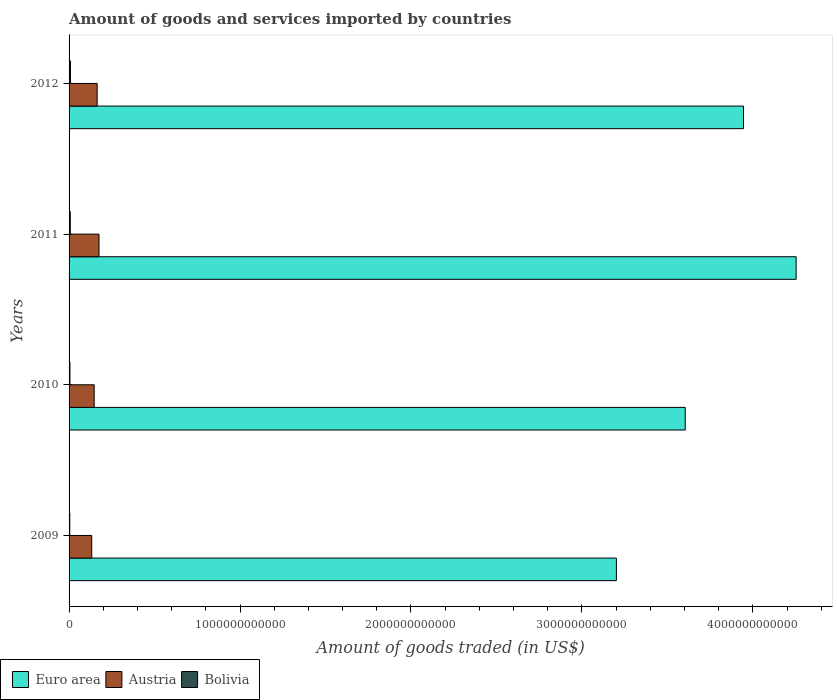How many different coloured bars are there?
Your answer should be very brief. 3. How many groups of bars are there?
Offer a very short reply. 4. How many bars are there on the 4th tick from the bottom?
Ensure brevity in your answer.  3. In how many cases, is the number of bars for a given year not equal to the number of legend labels?
Provide a succinct answer. 0. What is the total amount of goods and services imported in Euro area in 2010?
Your answer should be very brief. 3.60e+12. Across all years, what is the maximum total amount of goods and services imported in Bolivia?
Your answer should be compact. 8.00e+09. Across all years, what is the minimum total amount of goods and services imported in Euro area?
Your answer should be compact. 3.20e+12. In which year was the total amount of goods and services imported in Bolivia maximum?
Offer a terse response. 2012. In which year was the total amount of goods and services imported in Austria minimum?
Provide a short and direct response. 2009. What is the total total amount of goods and services imported in Bolivia in the graph?
Offer a terse response. 2.43e+1. What is the difference between the total amount of goods and services imported in Austria in 2010 and that in 2012?
Offer a terse response. -1.74e+1. What is the difference between the total amount of goods and services imported in Euro area in 2010 and the total amount of goods and services imported in Bolivia in 2009?
Provide a succinct answer. 3.60e+12. What is the average total amount of goods and services imported in Austria per year?
Your answer should be very brief. 1.55e+11. In the year 2009, what is the difference between the total amount of goods and services imported in Euro area and total amount of goods and services imported in Austria?
Your answer should be very brief. 3.07e+12. What is the ratio of the total amount of goods and services imported in Euro area in 2009 to that in 2010?
Your answer should be compact. 0.89. Is the total amount of goods and services imported in Austria in 2010 less than that in 2012?
Ensure brevity in your answer.  Yes. Is the difference between the total amount of goods and services imported in Euro area in 2010 and 2011 greater than the difference between the total amount of goods and services imported in Austria in 2010 and 2011?
Your answer should be very brief. No. What is the difference between the highest and the second highest total amount of goods and services imported in Euro area?
Your response must be concise. 3.08e+11. What is the difference between the highest and the lowest total amount of goods and services imported in Euro area?
Ensure brevity in your answer.  1.05e+12. Is the sum of the total amount of goods and services imported in Austria in 2009 and 2010 greater than the maximum total amount of goods and services imported in Euro area across all years?
Give a very brief answer. No. How many years are there in the graph?
Your answer should be very brief. 4. What is the difference between two consecutive major ticks on the X-axis?
Provide a succinct answer. 1.00e+12. Are the values on the major ticks of X-axis written in scientific E-notation?
Give a very brief answer. No. Does the graph contain any zero values?
Offer a very short reply. No. Does the graph contain grids?
Give a very brief answer. No. How are the legend labels stacked?
Provide a short and direct response. Horizontal. What is the title of the graph?
Provide a succinct answer. Amount of goods and services imported by countries. Does "Aruba" appear as one of the legend labels in the graph?
Ensure brevity in your answer.  No. What is the label or title of the X-axis?
Give a very brief answer. Amount of goods traded (in US$). What is the label or title of the Y-axis?
Keep it short and to the point. Years. What is the Amount of goods traded (in US$) of Euro area in 2009?
Make the answer very short. 3.20e+12. What is the Amount of goods traded (in US$) of Austria in 2009?
Ensure brevity in your answer.  1.32e+11. What is the Amount of goods traded (in US$) in Bolivia in 2009?
Make the answer very short. 4.14e+09. What is the Amount of goods traded (in US$) of Euro area in 2010?
Offer a very short reply. 3.60e+12. What is the Amount of goods traded (in US$) in Austria in 2010?
Offer a very short reply. 1.47e+11. What is the Amount of goods traded (in US$) of Bolivia in 2010?
Provide a short and direct response. 5.01e+09. What is the Amount of goods traded (in US$) of Euro area in 2011?
Keep it short and to the point. 4.25e+12. What is the Amount of goods traded (in US$) of Austria in 2011?
Your answer should be very brief. 1.75e+11. What is the Amount of goods traded (in US$) in Bolivia in 2011?
Your answer should be very brief. 7.13e+09. What is the Amount of goods traded (in US$) of Euro area in 2012?
Your answer should be compact. 3.95e+12. What is the Amount of goods traded (in US$) of Austria in 2012?
Offer a terse response. 1.64e+11. What is the Amount of goods traded (in US$) in Bolivia in 2012?
Your response must be concise. 8.00e+09. Across all years, what is the maximum Amount of goods traded (in US$) in Euro area?
Provide a short and direct response. 4.25e+12. Across all years, what is the maximum Amount of goods traded (in US$) in Austria?
Provide a succinct answer. 1.75e+11. Across all years, what is the maximum Amount of goods traded (in US$) in Bolivia?
Ensure brevity in your answer.  8.00e+09. Across all years, what is the minimum Amount of goods traded (in US$) of Euro area?
Keep it short and to the point. 3.20e+12. Across all years, what is the minimum Amount of goods traded (in US$) in Austria?
Your answer should be compact. 1.32e+11. Across all years, what is the minimum Amount of goods traded (in US$) of Bolivia?
Offer a terse response. 4.14e+09. What is the total Amount of goods traded (in US$) of Euro area in the graph?
Your answer should be compact. 1.50e+13. What is the total Amount of goods traded (in US$) of Austria in the graph?
Give a very brief answer. 6.19e+11. What is the total Amount of goods traded (in US$) of Bolivia in the graph?
Make the answer very short. 2.43e+1. What is the difference between the Amount of goods traded (in US$) in Euro area in 2009 and that in 2010?
Make the answer very short. -4.03e+11. What is the difference between the Amount of goods traded (in US$) in Austria in 2009 and that in 2010?
Make the answer very short. -1.45e+1. What is the difference between the Amount of goods traded (in US$) in Bolivia in 2009 and that in 2010?
Ensure brevity in your answer.  -8.63e+08. What is the difference between the Amount of goods traded (in US$) in Euro area in 2009 and that in 2011?
Offer a very short reply. -1.05e+12. What is the difference between the Amount of goods traded (in US$) in Austria in 2009 and that in 2011?
Your answer should be very brief. -4.28e+1. What is the difference between the Amount of goods traded (in US$) in Bolivia in 2009 and that in 2011?
Provide a succinct answer. -2.98e+09. What is the difference between the Amount of goods traded (in US$) in Euro area in 2009 and that in 2012?
Ensure brevity in your answer.  -7.43e+11. What is the difference between the Amount of goods traded (in US$) of Austria in 2009 and that in 2012?
Offer a terse response. -3.19e+1. What is the difference between the Amount of goods traded (in US$) in Bolivia in 2009 and that in 2012?
Offer a very short reply. -3.85e+09. What is the difference between the Amount of goods traded (in US$) of Euro area in 2010 and that in 2011?
Offer a very short reply. -6.49e+11. What is the difference between the Amount of goods traded (in US$) of Austria in 2010 and that in 2011?
Offer a terse response. -2.83e+1. What is the difference between the Amount of goods traded (in US$) in Bolivia in 2010 and that in 2011?
Offer a terse response. -2.12e+09. What is the difference between the Amount of goods traded (in US$) in Euro area in 2010 and that in 2012?
Offer a terse response. -3.41e+11. What is the difference between the Amount of goods traded (in US$) of Austria in 2010 and that in 2012?
Offer a terse response. -1.74e+1. What is the difference between the Amount of goods traded (in US$) in Bolivia in 2010 and that in 2012?
Offer a terse response. -2.99e+09. What is the difference between the Amount of goods traded (in US$) in Euro area in 2011 and that in 2012?
Keep it short and to the point. 3.08e+11. What is the difference between the Amount of goods traded (in US$) in Austria in 2011 and that in 2012?
Provide a succinct answer. 1.09e+1. What is the difference between the Amount of goods traded (in US$) of Bolivia in 2011 and that in 2012?
Offer a very short reply. -8.71e+08. What is the difference between the Amount of goods traded (in US$) in Euro area in 2009 and the Amount of goods traded (in US$) in Austria in 2010?
Ensure brevity in your answer.  3.06e+12. What is the difference between the Amount of goods traded (in US$) in Euro area in 2009 and the Amount of goods traded (in US$) in Bolivia in 2010?
Your answer should be compact. 3.20e+12. What is the difference between the Amount of goods traded (in US$) of Austria in 2009 and the Amount of goods traded (in US$) of Bolivia in 2010?
Your response must be concise. 1.27e+11. What is the difference between the Amount of goods traded (in US$) in Euro area in 2009 and the Amount of goods traded (in US$) in Austria in 2011?
Make the answer very short. 3.03e+12. What is the difference between the Amount of goods traded (in US$) of Euro area in 2009 and the Amount of goods traded (in US$) of Bolivia in 2011?
Your response must be concise. 3.19e+12. What is the difference between the Amount of goods traded (in US$) of Austria in 2009 and the Amount of goods traded (in US$) of Bolivia in 2011?
Offer a terse response. 1.25e+11. What is the difference between the Amount of goods traded (in US$) of Euro area in 2009 and the Amount of goods traded (in US$) of Austria in 2012?
Keep it short and to the point. 3.04e+12. What is the difference between the Amount of goods traded (in US$) of Euro area in 2009 and the Amount of goods traded (in US$) of Bolivia in 2012?
Make the answer very short. 3.19e+12. What is the difference between the Amount of goods traded (in US$) of Austria in 2009 and the Amount of goods traded (in US$) of Bolivia in 2012?
Provide a succinct answer. 1.24e+11. What is the difference between the Amount of goods traded (in US$) of Euro area in 2010 and the Amount of goods traded (in US$) of Austria in 2011?
Keep it short and to the point. 3.43e+12. What is the difference between the Amount of goods traded (in US$) in Euro area in 2010 and the Amount of goods traded (in US$) in Bolivia in 2011?
Your response must be concise. 3.60e+12. What is the difference between the Amount of goods traded (in US$) in Austria in 2010 and the Amount of goods traded (in US$) in Bolivia in 2011?
Provide a succinct answer. 1.40e+11. What is the difference between the Amount of goods traded (in US$) in Euro area in 2010 and the Amount of goods traded (in US$) in Austria in 2012?
Offer a terse response. 3.44e+12. What is the difference between the Amount of goods traded (in US$) in Euro area in 2010 and the Amount of goods traded (in US$) in Bolivia in 2012?
Offer a terse response. 3.60e+12. What is the difference between the Amount of goods traded (in US$) in Austria in 2010 and the Amount of goods traded (in US$) in Bolivia in 2012?
Keep it short and to the point. 1.39e+11. What is the difference between the Amount of goods traded (in US$) of Euro area in 2011 and the Amount of goods traded (in US$) of Austria in 2012?
Provide a short and direct response. 4.09e+12. What is the difference between the Amount of goods traded (in US$) in Euro area in 2011 and the Amount of goods traded (in US$) in Bolivia in 2012?
Offer a very short reply. 4.25e+12. What is the difference between the Amount of goods traded (in US$) of Austria in 2011 and the Amount of goods traded (in US$) of Bolivia in 2012?
Your response must be concise. 1.67e+11. What is the average Amount of goods traded (in US$) of Euro area per year?
Keep it short and to the point. 3.75e+12. What is the average Amount of goods traded (in US$) of Austria per year?
Offer a terse response. 1.55e+11. What is the average Amount of goods traded (in US$) of Bolivia per year?
Ensure brevity in your answer.  6.07e+09. In the year 2009, what is the difference between the Amount of goods traded (in US$) of Euro area and Amount of goods traded (in US$) of Austria?
Keep it short and to the point. 3.07e+12. In the year 2009, what is the difference between the Amount of goods traded (in US$) in Euro area and Amount of goods traded (in US$) in Bolivia?
Offer a very short reply. 3.20e+12. In the year 2009, what is the difference between the Amount of goods traded (in US$) in Austria and Amount of goods traded (in US$) in Bolivia?
Ensure brevity in your answer.  1.28e+11. In the year 2010, what is the difference between the Amount of goods traded (in US$) of Euro area and Amount of goods traded (in US$) of Austria?
Your answer should be very brief. 3.46e+12. In the year 2010, what is the difference between the Amount of goods traded (in US$) of Euro area and Amount of goods traded (in US$) of Bolivia?
Offer a very short reply. 3.60e+12. In the year 2010, what is the difference between the Amount of goods traded (in US$) of Austria and Amount of goods traded (in US$) of Bolivia?
Your response must be concise. 1.42e+11. In the year 2011, what is the difference between the Amount of goods traded (in US$) in Euro area and Amount of goods traded (in US$) in Austria?
Make the answer very short. 4.08e+12. In the year 2011, what is the difference between the Amount of goods traded (in US$) in Euro area and Amount of goods traded (in US$) in Bolivia?
Offer a very short reply. 4.25e+12. In the year 2011, what is the difference between the Amount of goods traded (in US$) of Austria and Amount of goods traded (in US$) of Bolivia?
Ensure brevity in your answer.  1.68e+11. In the year 2012, what is the difference between the Amount of goods traded (in US$) of Euro area and Amount of goods traded (in US$) of Austria?
Keep it short and to the point. 3.78e+12. In the year 2012, what is the difference between the Amount of goods traded (in US$) in Euro area and Amount of goods traded (in US$) in Bolivia?
Your response must be concise. 3.94e+12. In the year 2012, what is the difference between the Amount of goods traded (in US$) in Austria and Amount of goods traded (in US$) in Bolivia?
Keep it short and to the point. 1.56e+11. What is the ratio of the Amount of goods traded (in US$) of Euro area in 2009 to that in 2010?
Offer a very short reply. 0.89. What is the ratio of the Amount of goods traded (in US$) of Austria in 2009 to that in 2010?
Provide a short and direct response. 0.9. What is the ratio of the Amount of goods traded (in US$) in Bolivia in 2009 to that in 2010?
Keep it short and to the point. 0.83. What is the ratio of the Amount of goods traded (in US$) of Euro area in 2009 to that in 2011?
Your response must be concise. 0.75. What is the ratio of the Amount of goods traded (in US$) of Austria in 2009 to that in 2011?
Make the answer very short. 0.76. What is the ratio of the Amount of goods traded (in US$) in Bolivia in 2009 to that in 2011?
Ensure brevity in your answer.  0.58. What is the ratio of the Amount of goods traded (in US$) in Euro area in 2009 to that in 2012?
Give a very brief answer. 0.81. What is the ratio of the Amount of goods traded (in US$) of Austria in 2009 to that in 2012?
Ensure brevity in your answer.  0.81. What is the ratio of the Amount of goods traded (in US$) in Bolivia in 2009 to that in 2012?
Offer a very short reply. 0.52. What is the ratio of the Amount of goods traded (in US$) in Euro area in 2010 to that in 2011?
Your answer should be very brief. 0.85. What is the ratio of the Amount of goods traded (in US$) of Austria in 2010 to that in 2011?
Keep it short and to the point. 0.84. What is the ratio of the Amount of goods traded (in US$) of Bolivia in 2010 to that in 2011?
Offer a very short reply. 0.7. What is the ratio of the Amount of goods traded (in US$) of Euro area in 2010 to that in 2012?
Provide a short and direct response. 0.91. What is the ratio of the Amount of goods traded (in US$) of Austria in 2010 to that in 2012?
Offer a terse response. 0.89. What is the ratio of the Amount of goods traded (in US$) in Bolivia in 2010 to that in 2012?
Keep it short and to the point. 0.63. What is the ratio of the Amount of goods traded (in US$) of Euro area in 2011 to that in 2012?
Your answer should be compact. 1.08. What is the ratio of the Amount of goods traded (in US$) in Austria in 2011 to that in 2012?
Give a very brief answer. 1.07. What is the ratio of the Amount of goods traded (in US$) of Bolivia in 2011 to that in 2012?
Give a very brief answer. 0.89. What is the difference between the highest and the second highest Amount of goods traded (in US$) in Euro area?
Your answer should be compact. 3.08e+11. What is the difference between the highest and the second highest Amount of goods traded (in US$) of Austria?
Keep it short and to the point. 1.09e+1. What is the difference between the highest and the second highest Amount of goods traded (in US$) of Bolivia?
Offer a very short reply. 8.71e+08. What is the difference between the highest and the lowest Amount of goods traded (in US$) in Euro area?
Your response must be concise. 1.05e+12. What is the difference between the highest and the lowest Amount of goods traded (in US$) in Austria?
Keep it short and to the point. 4.28e+1. What is the difference between the highest and the lowest Amount of goods traded (in US$) in Bolivia?
Give a very brief answer. 3.85e+09. 